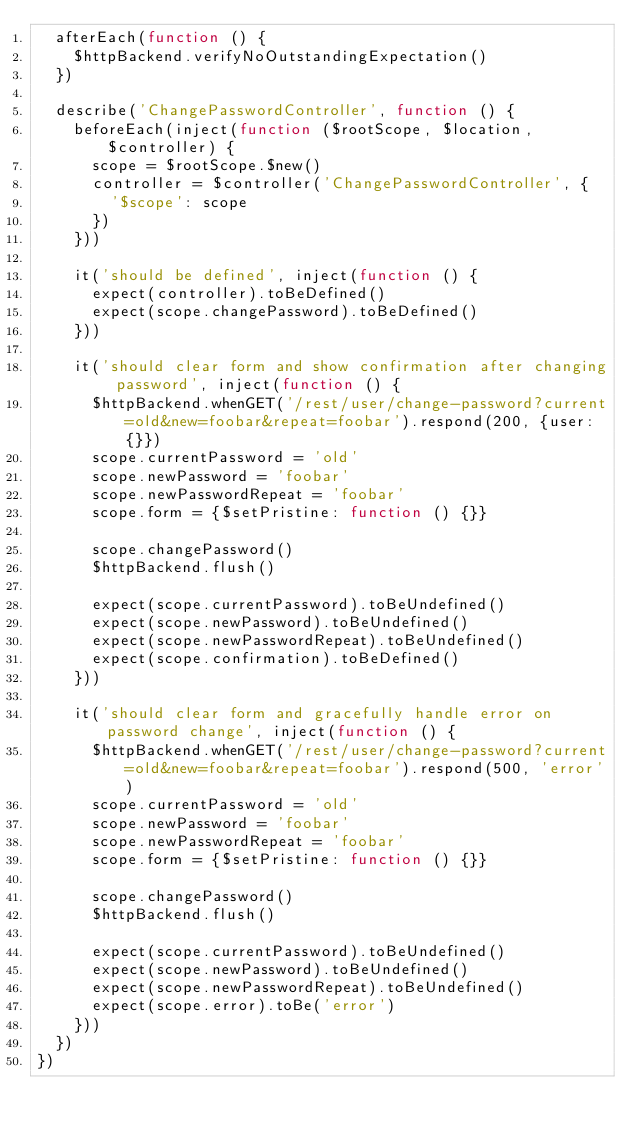<code> <loc_0><loc_0><loc_500><loc_500><_JavaScript_>  afterEach(function () {
    $httpBackend.verifyNoOutstandingExpectation()
  })

  describe('ChangePasswordController', function () {
    beforeEach(inject(function ($rootScope, $location, $controller) {
      scope = $rootScope.$new()
      controller = $controller('ChangePasswordController', {
        '$scope': scope
      })
    }))

    it('should be defined', inject(function () {
      expect(controller).toBeDefined()
      expect(scope.changePassword).toBeDefined()
    }))

    it('should clear form and show confirmation after changing password', inject(function () {
      $httpBackend.whenGET('/rest/user/change-password?current=old&new=foobar&repeat=foobar').respond(200, {user: {}})
      scope.currentPassword = 'old'
      scope.newPassword = 'foobar'
      scope.newPasswordRepeat = 'foobar'
      scope.form = {$setPristine: function () {}}

      scope.changePassword()
      $httpBackend.flush()

      expect(scope.currentPassword).toBeUndefined()
      expect(scope.newPassword).toBeUndefined()
      expect(scope.newPasswordRepeat).toBeUndefined()
      expect(scope.confirmation).toBeDefined()
    }))

    it('should clear form and gracefully handle error on password change', inject(function () {
      $httpBackend.whenGET('/rest/user/change-password?current=old&new=foobar&repeat=foobar').respond(500, 'error')
      scope.currentPassword = 'old'
      scope.newPassword = 'foobar'
      scope.newPasswordRepeat = 'foobar'
      scope.form = {$setPristine: function () {}}

      scope.changePassword()
      $httpBackend.flush()

      expect(scope.currentPassword).toBeUndefined()
      expect(scope.newPassword).toBeUndefined()
      expect(scope.newPasswordRepeat).toBeUndefined()
      expect(scope.error).toBe('error')
    }))
  })
})
</code> 